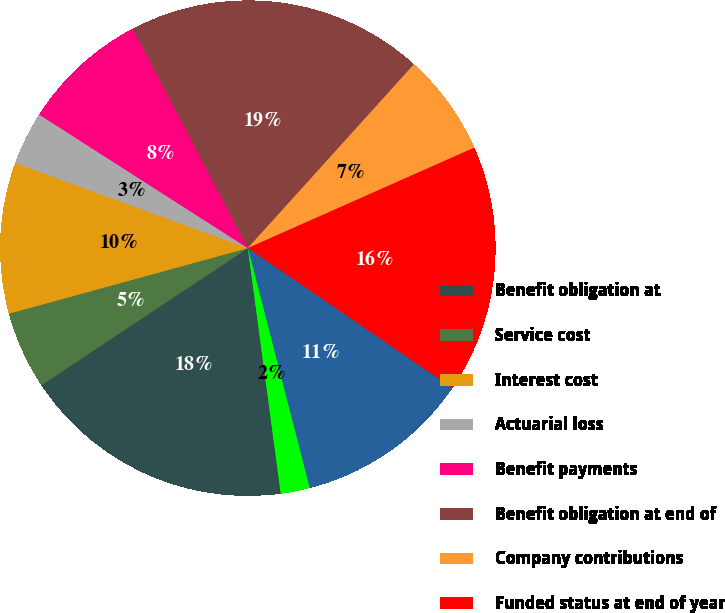Convert chart to OTSL. <chart><loc_0><loc_0><loc_500><loc_500><pie_chart><fcel>Benefit obligation at<fcel>Service cost<fcel>Interest cost<fcel>Actuarial loss<fcel>Benefit payments<fcel>Benefit obligation at end of<fcel>Company contributions<fcel>Funded status at end of year<fcel>Unrecognized net actuarial<fcel>Unrecognized transition/prior<nl><fcel>17.79%<fcel>5.07%<fcel>9.84%<fcel>3.48%<fcel>8.25%<fcel>19.38%<fcel>6.66%<fcel>16.2%<fcel>11.43%<fcel>1.89%<nl></chart> 